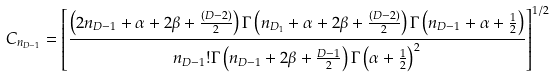Convert formula to latex. <formula><loc_0><loc_0><loc_500><loc_500>C _ { n _ { D - 1 } } = \left [ \frac { \left ( 2 n _ { D - 1 } + \alpha + 2 \beta + \frac { ( D - 2 ) } { 2 } \right ) \Gamma \left ( n _ { D _ { 1 } } + \alpha + 2 \beta + \frac { ( D - 2 ) } { 2 } \right ) \Gamma \left ( n _ { D - 1 } + \alpha + \frac { 1 } { 2 } \right ) } { n _ { D - 1 } ! \Gamma \left ( n _ { D - 1 } + 2 \beta + \frac { D - 1 } { 2 } \right ) \Gamma \left ( \alpha + \frac { 1 } { 2 } \right ) ^ { 2 } } \right ] ^ { 1 / 2 }</formula> 